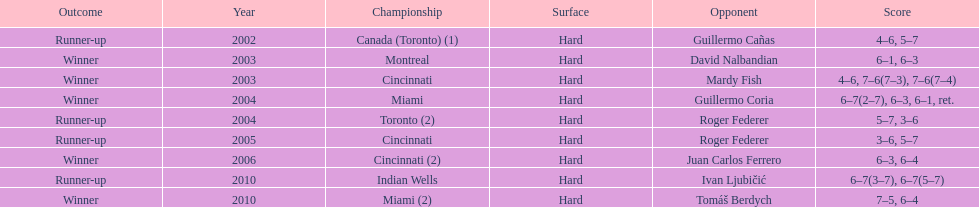Can you give me this table as a dict? {'header': ['Outcome', 'Year', 'Championship', 'Surface', 'Opponent', 'Score'], 'rows': [['Runner-up', '2002', 'Canada (Toronto) (1)', 'Hard', 'Guillermo Cañas', '4–6, 5–7'], ['Winner', '2003', 'Montreal', 'Hard', 'David Nalbandian', '6–1, 6–3'], ['Winner', '2003', 'Cincinnati', 'Hard', 'Mardy Fish', '4–6, 7–6(7–3), 7–6(7–4)'], ['Winner', '2004', 'Miami', 'Hard', 'Guillermo Coria', '6–7(2–7), 6–3, 6–1, ret.'], ['Runner-up', '2004', 'Toronto (2)', 'Hard', 'Roger Federer', '5–7, 3–6'], ['Runner-up', '2005', 'Cincinnati', 'Hard', 'Roger Federer', '3–6, 5–7'], ['Winner', '2006', 'Cincinnati (2)', 'Hard', 'Juan Carlos Ferrero', '6–3, 6–4'], ['Runner-up', '2010', 'Indian Wells', 'Hard', 'Ivan Ljubičić', '6–7(3–7), 6–7(5–7)'], ['Winner', '2010', 'Miami (2)', 'Hard', 'Tomáš Berdych', '7–5, 6–4']]} How many successive years was there a hard surface at the championship? 9. 